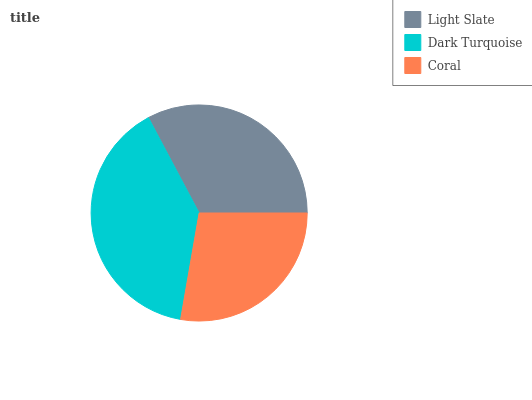Is Coral the minimum?
Answer yes or no. Yes. Is Dark Turquoise the maximum?
Answer yes or no. Yes. Is Dark Turquoise the minimum?
Answer yes or no. No. Is Coral the maximum?
Answer yes or no. No. Is Dark Turquoise greater than Coral?
Answer yes or no. Yes. Is Coral less than Dark Turquoise?
Answer yes or no. Yes. Is Coral greater than Dark Turquoise?
Answer yes or no. No. Is Dark Turquoise less than Coral?
Answer yes or no. No. Is Light Slate the high median?
Answer yes or no. Yes. Is Light Slate the low median?
Answer yes or no. Yes. Is Coral the high median?
Answer yes or no. No. Is Coral the low median?
Answer yes or no. No. 